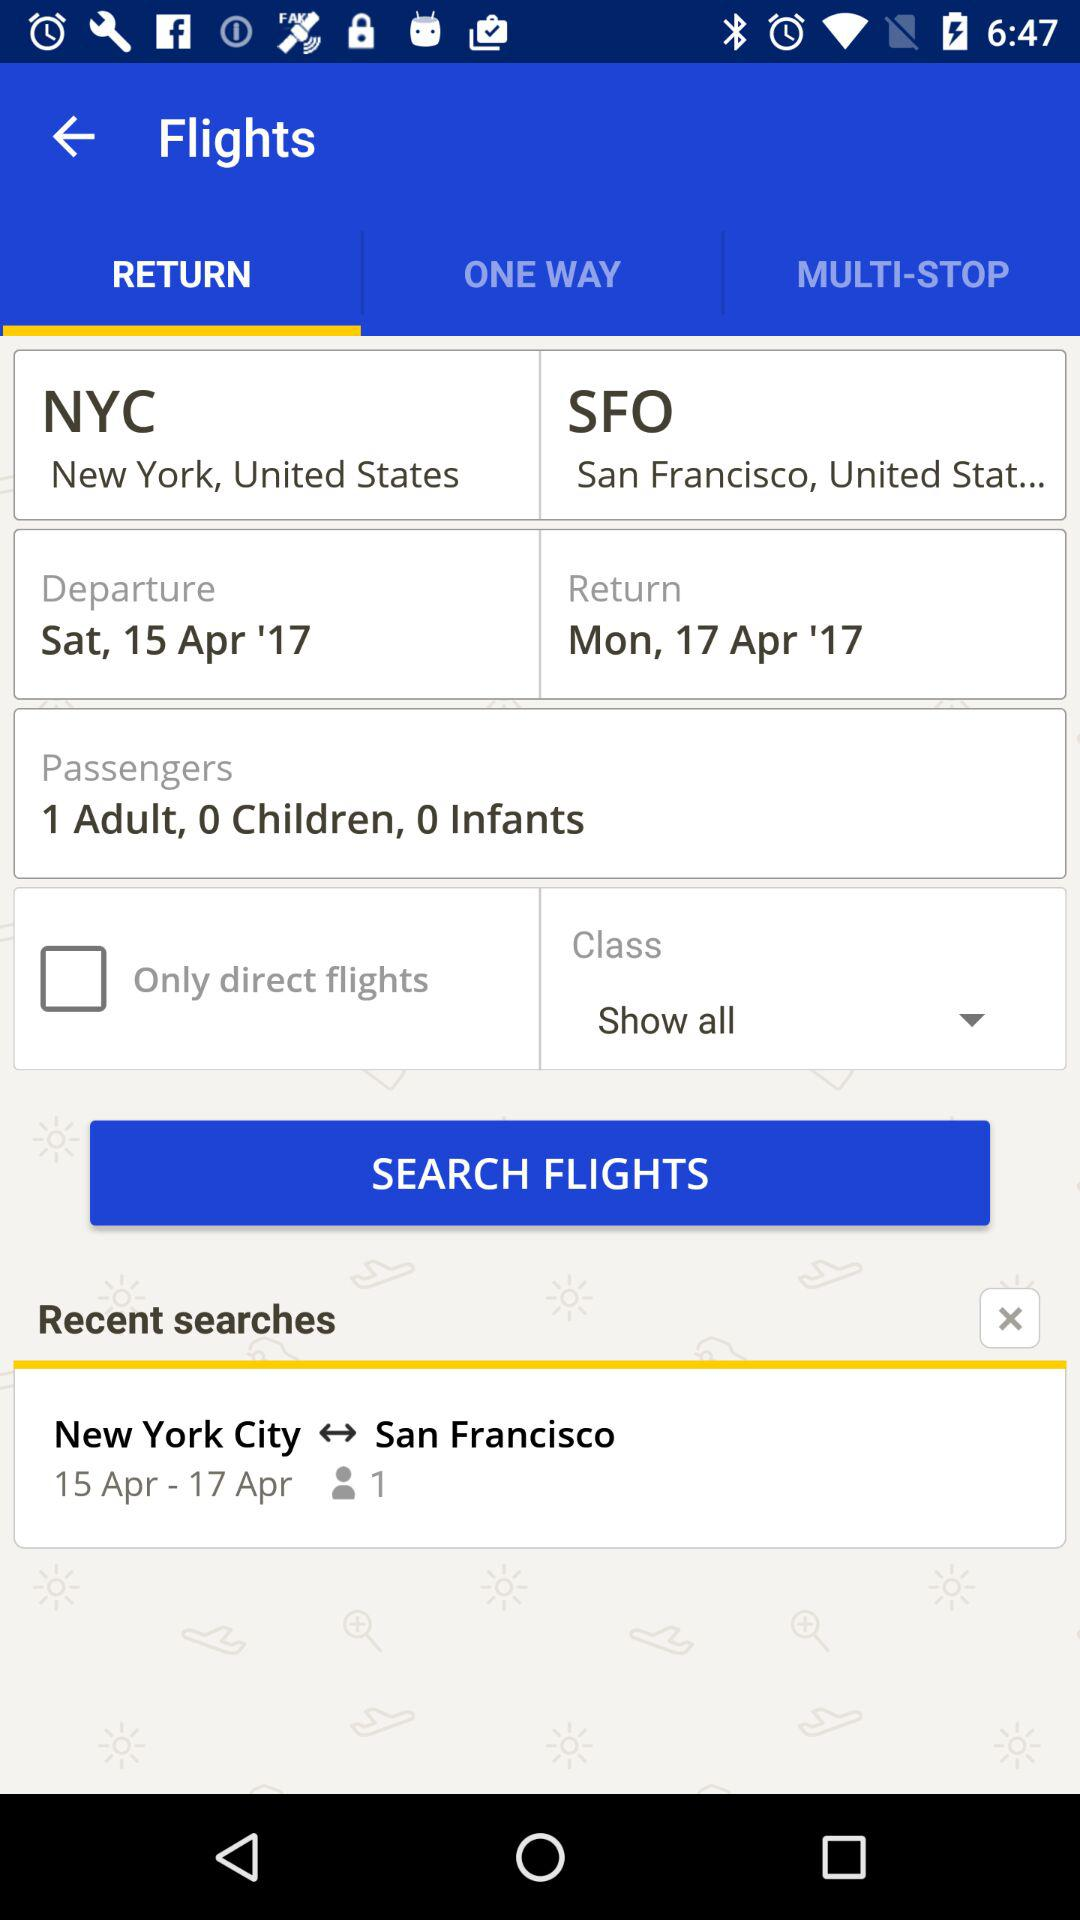From where is the flight? The flight departs from New York, United States. 